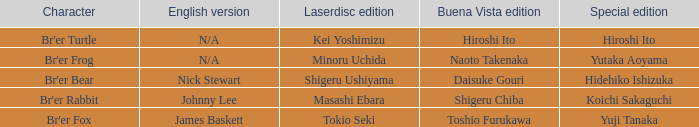What is the special edition for the english version of james baskett? Yuji Tanaka. 